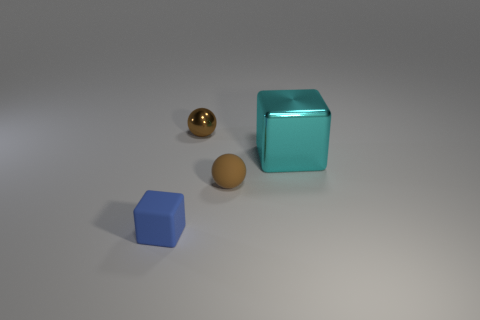What is the color of the largest object in the image? The largest object in the image is a teal-colored cube. 